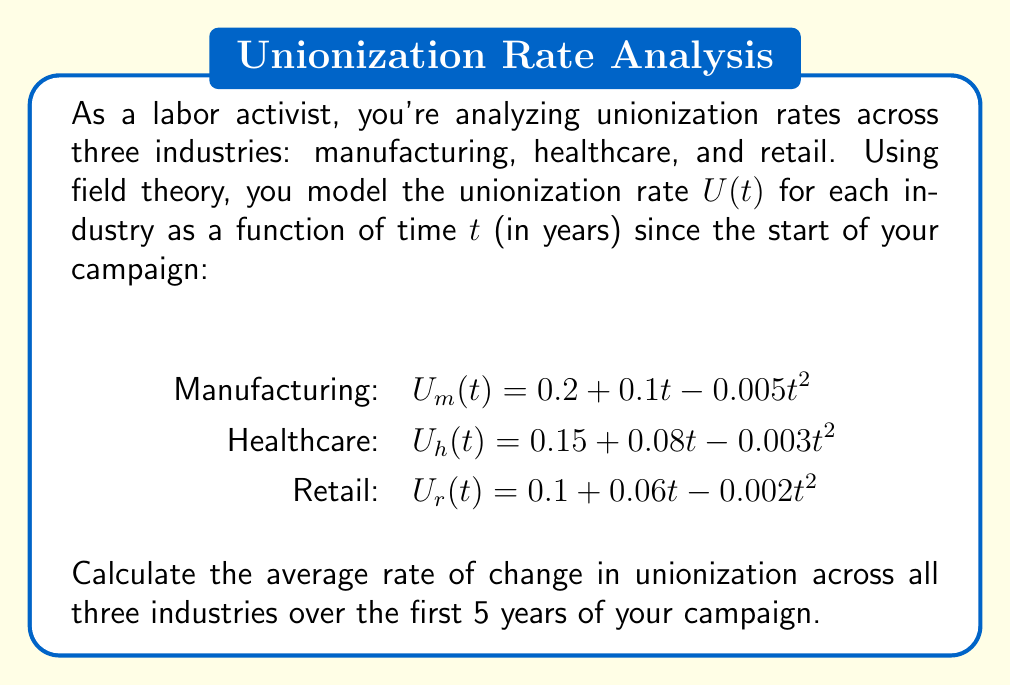Could you help me with this problem? To solve this problem, we'll follow these steps:

1) First, we need to calculate the change in unionization rate for each industry over the 5-year period.

2) For each industry, we'll use the formula:
   $\Delta U = U(5) - U(0)$

3) Manufacturing:
   $U_m(0) = 0.2 + 0.1(0) - 0.005(0)^2 = 0.2$
   $U_m(5) = 0.2 + 0.1(5) - 0.005(5)^2 = 0.575$
   $\Delta U_m = 0.575 - 0.2 = 0.375$

4) Healthcare:
   $U_h(0) = 0.15 + 0.08(0) - 0.003(0)^2 = 0.15$
   $U_h(5) = 0.15 + 0.08(5) - 0.003(5)^2 = 0.475$
   $\Delta U_h = 0.475 - 0.15 = 0.325$

5) Retail:
   $U_r(0) = 0.1 + 0.06(0) - 0.002(0)^2 = 0.1$
   $U_r(5) = 0.1 + 0.06(5) - 0.002(5)^2 = 0.35$
   $\Delta U_r = 0.35 - 0.1 = 0.25$

6) Now, we calculate the average change across all three industries:
   $\text{Average } \Delta U = \frac{\Delta U_m + \Delta U_h + \Delta U_r}{3}$
   $= \frac{0.375 + 0.325 + 0.25}{3} = 0.3167$

7) To get the average rate of change per year, we divide by the time period (5 years):
   $\text{Average rate of change} = \frac{0.3167}{5} = 0.06333$
Answer: $0.06333$ or $6.333\%$ per year 